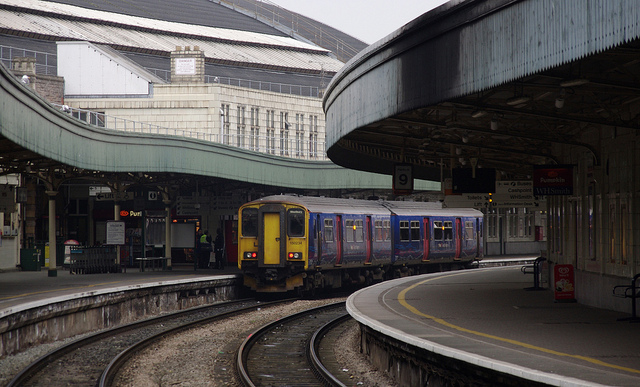Please extract the text content from this image. 9 